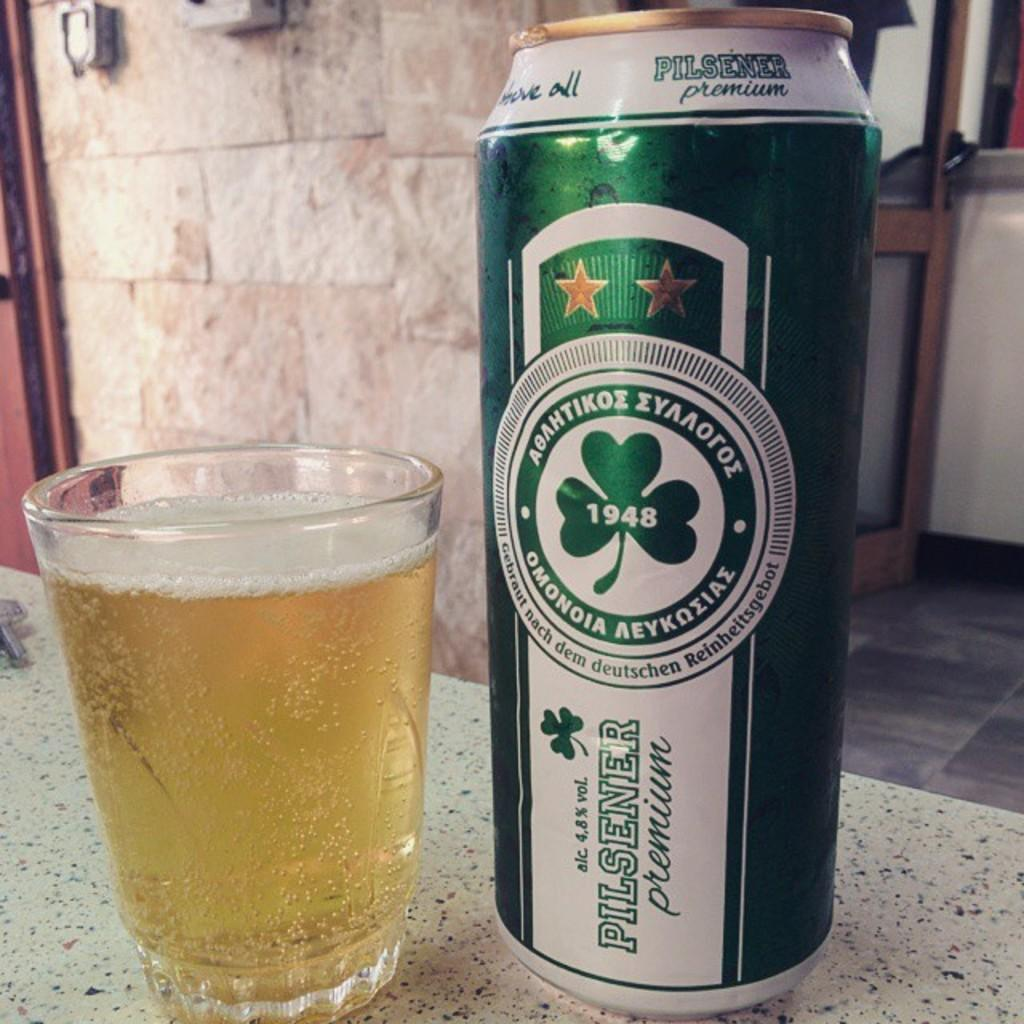<image>
Relay a brief, clear account of the picture shown. Green and white Pilsener Premium beer bottle next to a cup of beer. 